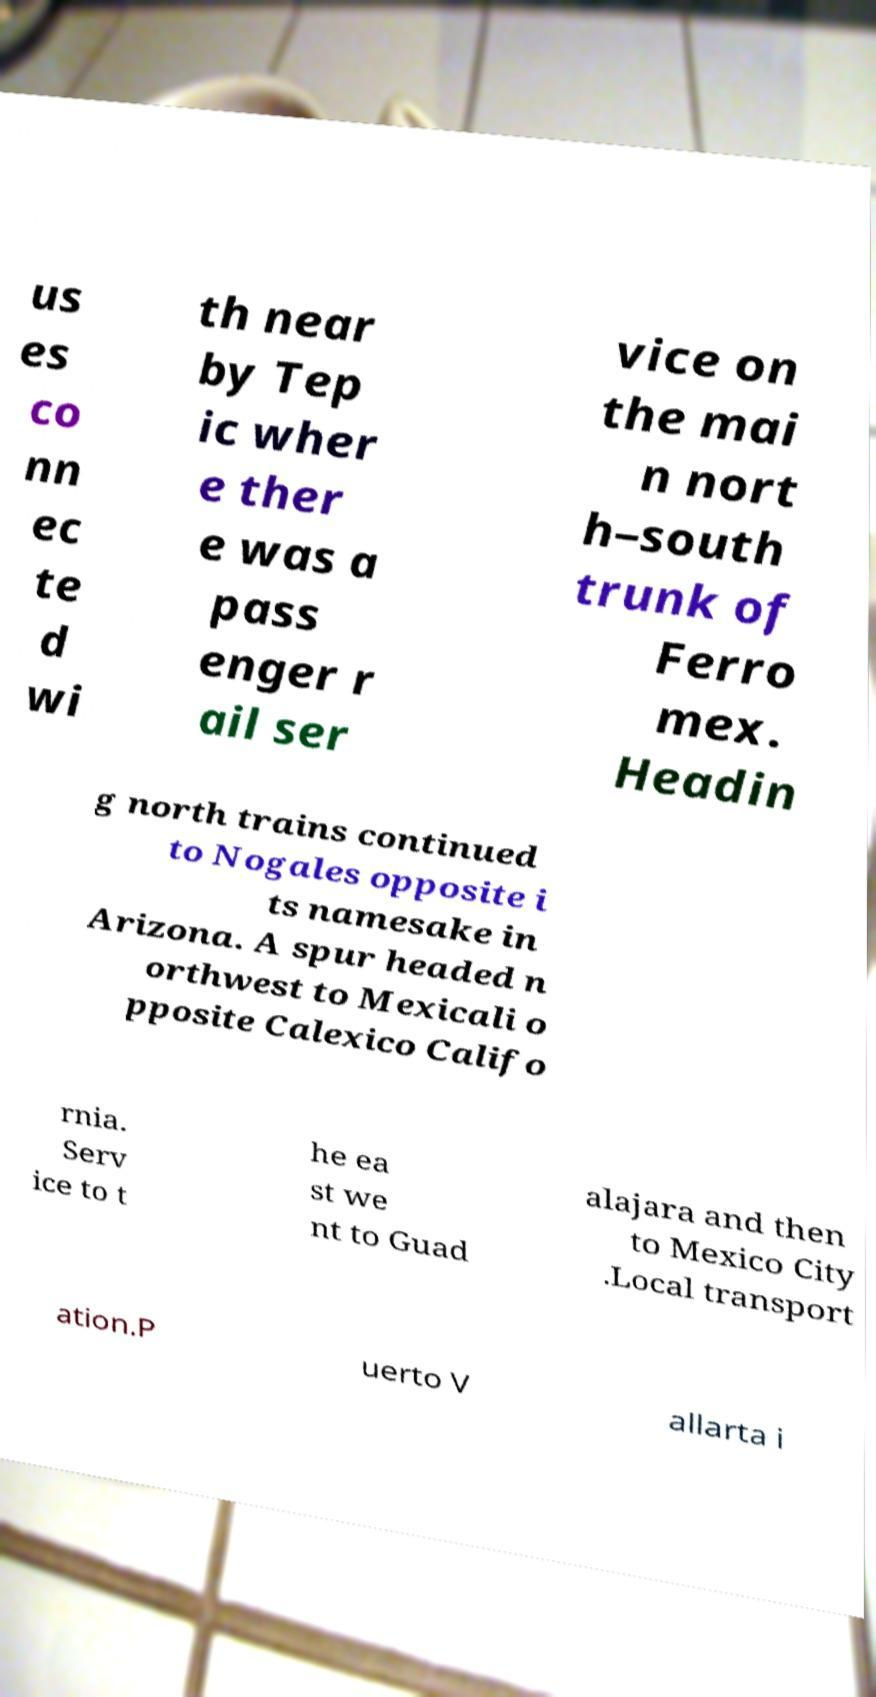Please identify and transcribe the text found in this image. us es co nn ec te d wi th near by Tep ic wher e ther e was a pass enger r ail ser vice on the mai n nort h–south trunk of Ferro mex. Headin g north trains continued to Nogales opposite i ts namesake in Arizona. A spur headed n orthwest to Mexicali o pposite Calexico Califo rnia. Serv ice to t he ea st we nt to Guad alajara and then to Mexico City .Local transport ation.P uerto V allarta i 